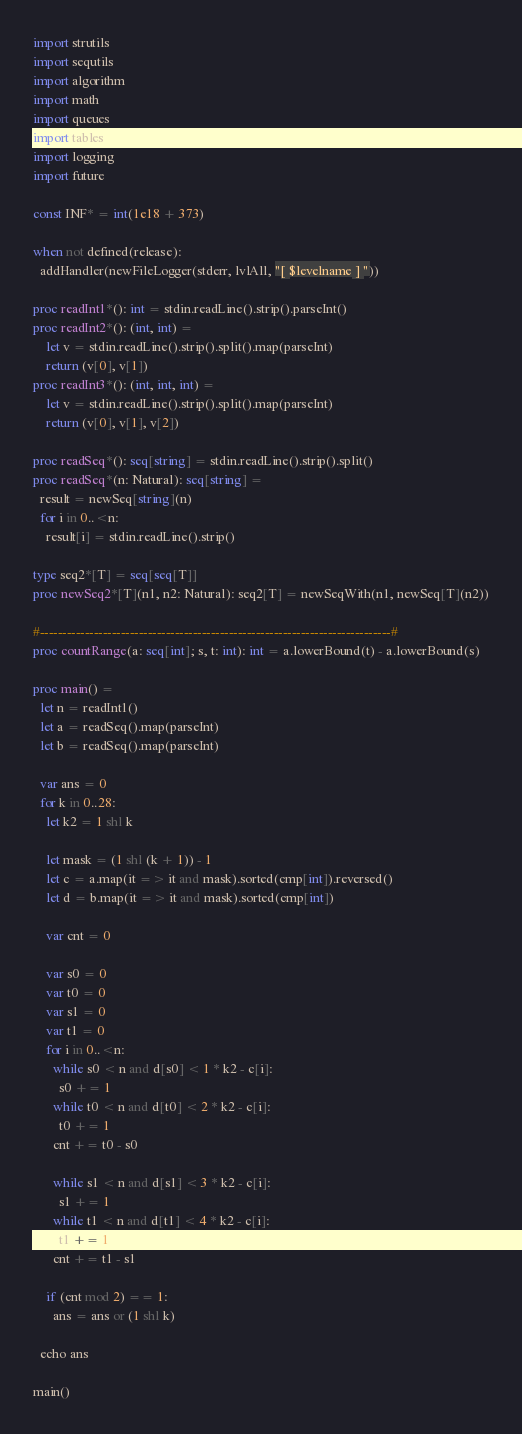Convert code to text. <code><loc_0><loc_0><loc_500><loc_500><_Nim_>import strutils
import sequtils
import algorithm
import math
import queues
import tables
import logging
import future

const INF* = int(1e18 + 373)

when not defined(release):
  addHandler(newFileLogger(stderr, lvlAll, "[ $levelname ] "))

proc readInt1*(): int = stdin.readLine().strip().parseInt()
proc readInt2*(): (int, int) =
    let v = stdin.readLine().strip().split().map(parseInt)
    return (v[0], v[1])
proc readInt3*(): (int, int, int) =
    let v = stdin.readLine().strip().split().map(parseInt)
    return (v[0], v[1], v[2])

proc readSeq*(): seq[string] = stdin.readLine().strip().split()
proc readSeq*(n: Natural): seq[string] =
  result = newSeq[string](n)
  for i in 0..<n:
    result[i] = stdin.readLine().strip()

type seq2*[T] = seq[seq[T]]
proc newSeq2*[T](n1, n2: Natural): seq2[T] = newSeqWith(n1, newSeq[T](n2))

#------------------------------------------------------------------------------#
proc countRange(a: seq[int]; s, t: int): int = a.lowerBound(t) - a.lowerBound(s)

proc main() =
  let n = readInt1()
  let a = readSeq().map(parseInt)
  let b = readSeq().map(parseInt)

  var ans = 0
  for k in 0..28:
    let k2 = 1 shl k

    let mask = (1 shl (k + 1)) - 1
    let c = a.map(it => it and mask).sorted(cmp[int]).reversed()
    let d = b.map(it => it and mask).sorted(cmp[int])

    var cnt = 0

    var s0 = 0
    var t0 = 0
    var s1 = 0
    var t1 = 0
    for i in 0..<n:
      while s0 < n and d[s0] < 1 * k2 - c[i]:
        s0 += 1
      while t0 < n and d[t0] < 2 * k2 - c[i]:
        t0 += 1
      cnt += t0 - s0

      while s1 < n and d[s1] < 3 * k2 - c[i]:
        s1 += 1
      while t1 < n and d[t1] < 4 * k2 - c[i]:
        t1 += 1
      cnt += t1 - s1

    if (cnt mod 2) == 1:
      ans = ans or (1 shl k)

  echo ans

main()

</code> 